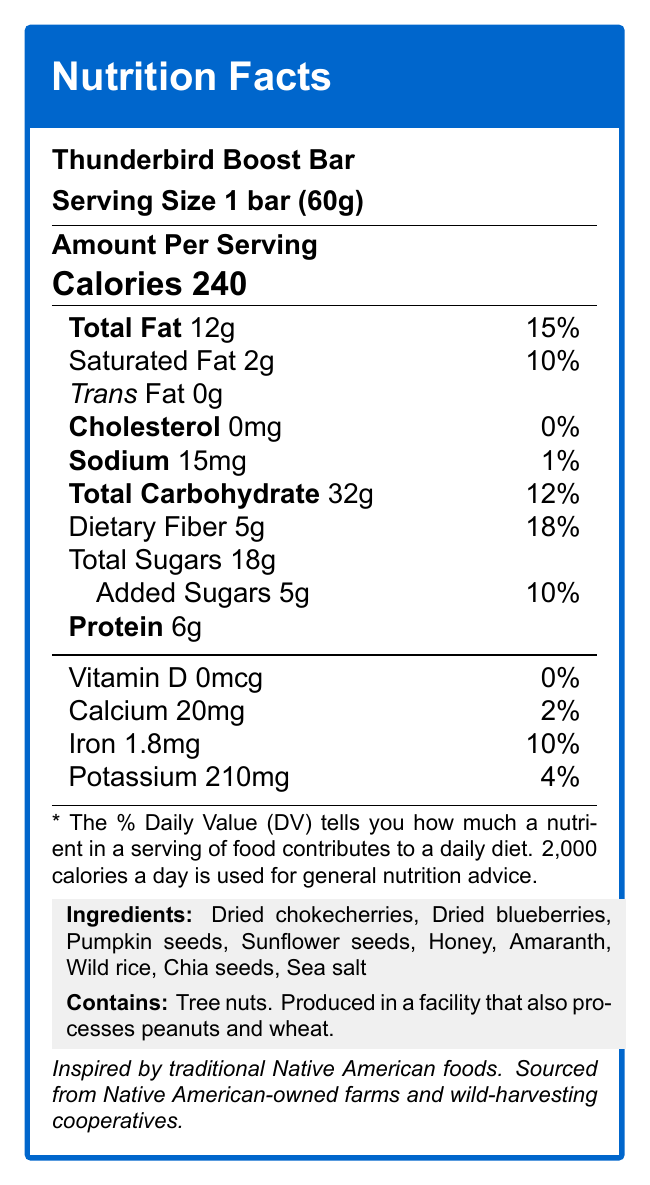what is the serving size of the Thunderbird Boost Bar? The document specifies the serving size clearly under the product name as "Serving Size 1 bar (60g)."
Answer: 1 bar (60g) how many calories are there per serving? The document under "Amount Per Serving" states "Calories 240".
Answer: 240 what is the daily value percentage of iron in the bar? The nutrition facts table lists iron as 1.8mg with a daily value of 10%.
Answer: 10% what type of facility is the bar produced in? The allergen information states, "Produced in a facility that also processes peanuts and wheat."
Answer: A facility that processes peanuts and wheat what are the ingredients of the Thunderbird Boost Bar? The ingredients are listed under the ingredients section in the document.
Answer: Dried chokecherries, Dried blueberries, Pumpkin seeds, Sunflower seeds, Honey, Amaranth, Wild rice, Chia seeds, Sea salt which ingredient contributes the most to dietary fiber? A. Dried blueberries B. Pumpkin seeds C. Chia seeds D. Amaranth Chia seeds are known for their high dietary fiber content, making option C the correct choice.
Answer: C how much potassium does the bar contain? A. 150mg B. 60mg C. 210mg D. 200mg The document lists potassium as 210mg, making option C correct.
Answer: C does the bar contain any trans fat? The nutrition facts table lists "Trans Fat 0g," indicating the bar contains no trans fat.
Answer: No is the Thunderbird Boost Bar sourced sustainably? The sustainability note mentions ingredients are sourced from Native American-owned farms and wild-harvesting cooperatives, supporting local economies and traditional agricultural practices.
Answer: Yes what is the cultural significance of the Thunderbird Boost Bar? The cultural significance section explains the energy bar is inspired by traditional Native American foods, providing sustained energy and reflecting the harmony between nature and nutrition.
Answer: Reflects traditional Native American foods and the harmony between nature and nutrition does the bar contain added sugars? The nutrition facts table lists "Added Sugars 5g," indicating the bar does contain added sugars.
Answer: Yes summarize the main idea of the nutrition facts label for the Thunderbird Boost Bar. The summary captures the key nutritional details, ingredients, cultural and sustainability aspects of the Thunderbird Boost Bar as presented in the document.
Answer: The Thunderbird Boost Bar is a traditional Native American energy bar featuring sustainable ingredients like berries, seeds, and grains. It provides 240 calories per serving, has 12g of total fat, 32g of carbohydrates, and 6g of protein. The bar is low in sodium and cholesterol, but rich in dietary fiber and iron. Sourced responsibly, it supports Native American agricultural practices. how much vitamin D does the bar provide? The nutrition facts table lists vitamin D as 0mcg, indicating no vitamin D is provided by the bar.
Answer: 0mcg which nutrient contributes the highest percentage of daily value in the bar? A. Protein B. Dietary Fiber C. Sodium D. Calcium The document lists dietary fiber with an 18% daily value contribution, which is higher than the others listed options.
Answer: B which ingredient is not present in the Thunderbird Boost Bar? The document only lists the ingredients that are present in the bar; it does not provide a list of what might not be included, thus information is insufficient.
Answer: Not enough information 